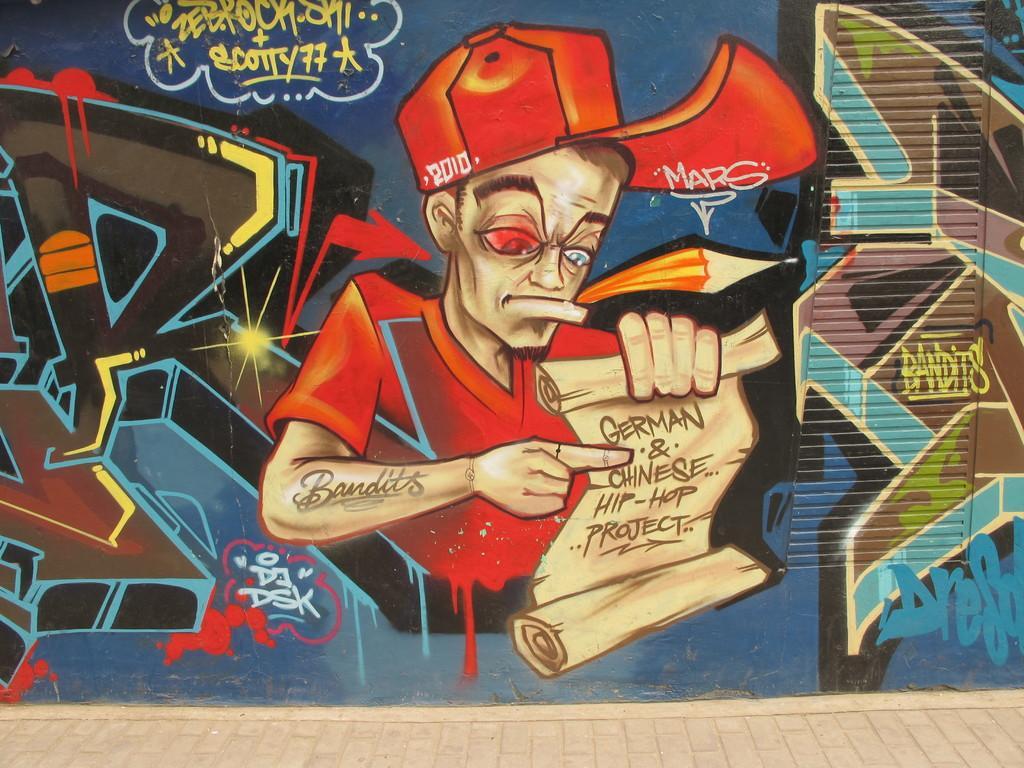Please provide a concise description of this image. There is a painting on a wall, the painting of a man holding some note and his hand is drawn on the wall. 